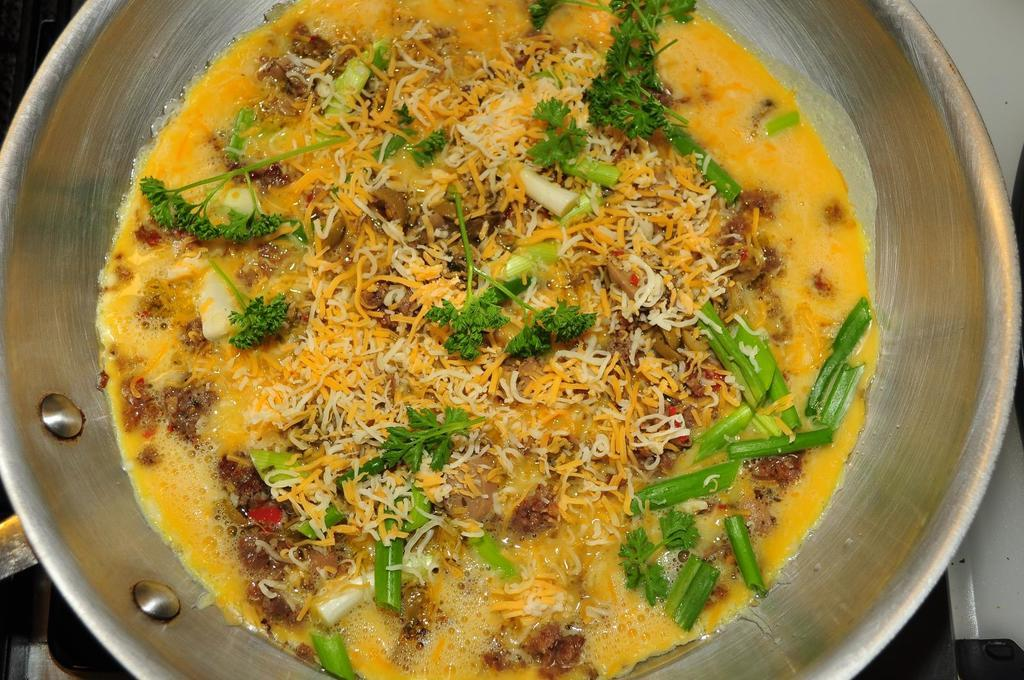What is the main subject in the image? There is a food item in a bowl in the image. How many babies are visible in the image? There are no babies present in the image. What type of calendar is shown on the wall in the image? There is no wall or calendar present in the image. 